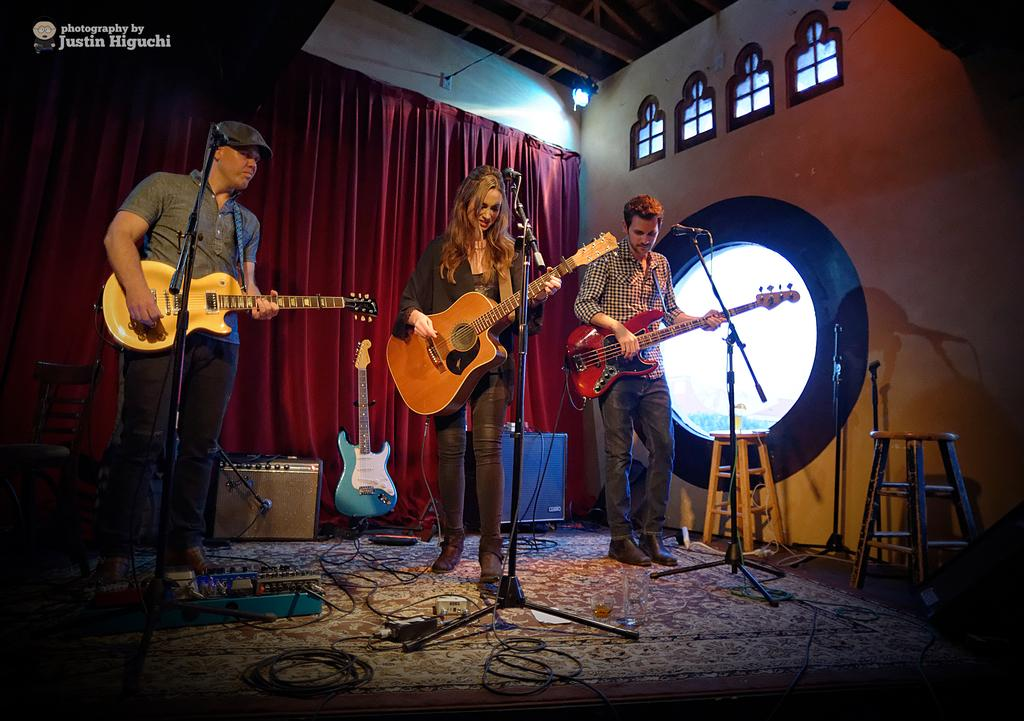How many people are in the image? There are three persons in the image. What are the persons doing in the image? The persons are standing on the floor and playing guitars. What objects are present in the image that might be used for amplifying sound? There are microphones in the image. What can be seen in the background of the image? There is a curtain and a wall in the background of the image. What type of desk can be seen in the image? There is no desk present in the image. Is there a canvas visible in the image? There is no canvas present in the image. 